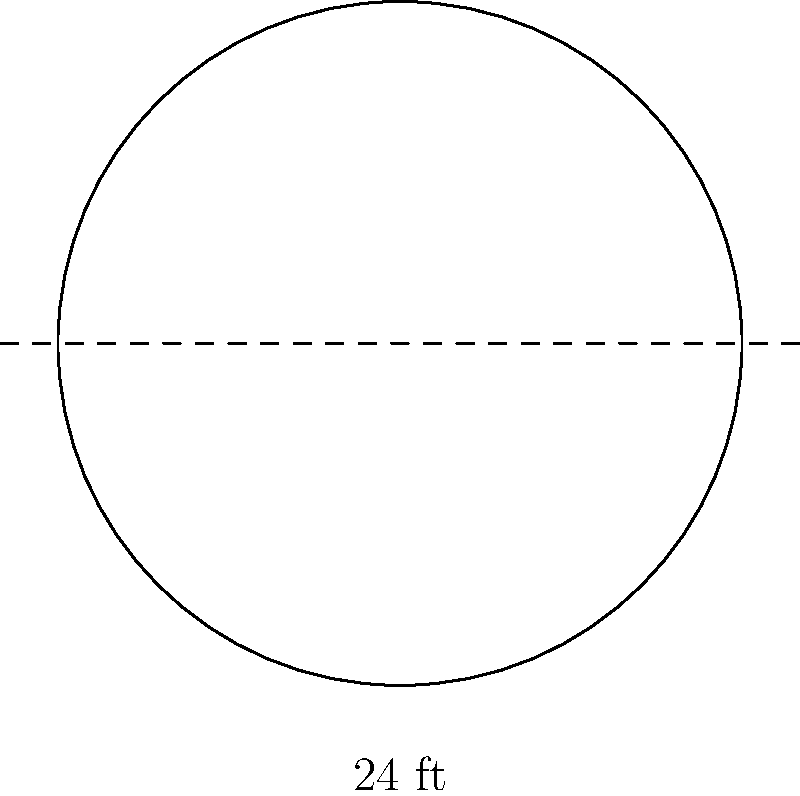At a new high-end restaurant in Las Vegas, you're seated at a circular dining table with a diameter of 24 feet. What is the area of this luxurious table's surface? To find the area of the circular dining table, we'll follow these steps:

1. Recall the formula for the area of a circle: $A = \pi r^2$, where $r$ is the radius.

2. We're given the diameter, which is 24 feet. The radius is half of the diameter:
   $r = \frac{24}{2} = 12$ feet

3. Now, let's substitute this into our area formula:
   $A = \pi (12)^2$

4. Simplify:
   $A = \pi (144)$

5. Calculate (using $\pi \approx 3.14159$):
   $A \approx 3.14159 \times 144 \approx 452.39$ square feet

6. Round to two decimal places:
   $A \approx 452.39$ square feet
Answer: $452.39$ sq ft 